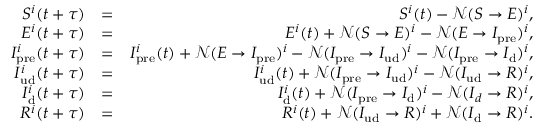Convert formula to latex. <formula><loc_0><loc_0><loc_500><loc_500>\begin{array} { r l r } { S ^ { i } ( t + \tau ) } & { = } & { S ^ { i } ( t ) - \mathcal { N } ( S \rightarrow E ) ^ { i } , } \\ { E ^ { i } ( t + \tau ) } & { = } & { E ^ { i } ( t ) + \mathcal { N } ( S \rightarrow E ) ^ { i } - \mathcal { N } ( E \rightarrow I _ { p r e } ) ^ { i } , } \\ { I _ { p r e } ^ { i } ( t + \tau ) } & { = } & { I _ { p r e } ^ { i } ( t ) + \mathcal { N } ( E \rightarrow I _ { p r e } ) ^ { i } - \mathcal { N } ( I _ { p r e } \rightarrow I _ { u d } ) ^ { i } - \mathcal { N } ( I _ { p r e } \rightarrow I _ { d } ) ^ { i } , } \\ { I _ { u d } ^ { i } ( t + \tau ) } & { = } & { I _ { u d } ^ { i } ( t ) + \mathcal { N } ( I _ { p r e } \rightarrow I _ { u d } ) ^ { i } - \mathcal { N } ( I _ { u d } \rightarrow R ) ^ { i } , } \\ { I _ { d } ^ { i } ( t + \tau ) } & { = } & { I _ { d } ^ { i } ( t ) + \mathcal { N } ( I _ { p r e } \rightarrow I _ { d } ) ^ { i } - \mathcal { N } ( I _ { d } \rightarrow R ) ^ { i } , } \\ { R ^ { i } ( t + \tau ) } & { = } & { R ^ { i } ( t ) + \mathcal { N } ( I _ { u d } \rightarrow R ) ^ { i } + \mathcal { N } ( I _ { d } \rightarrow R ) ^ { i } . } \end{array}</formula> 